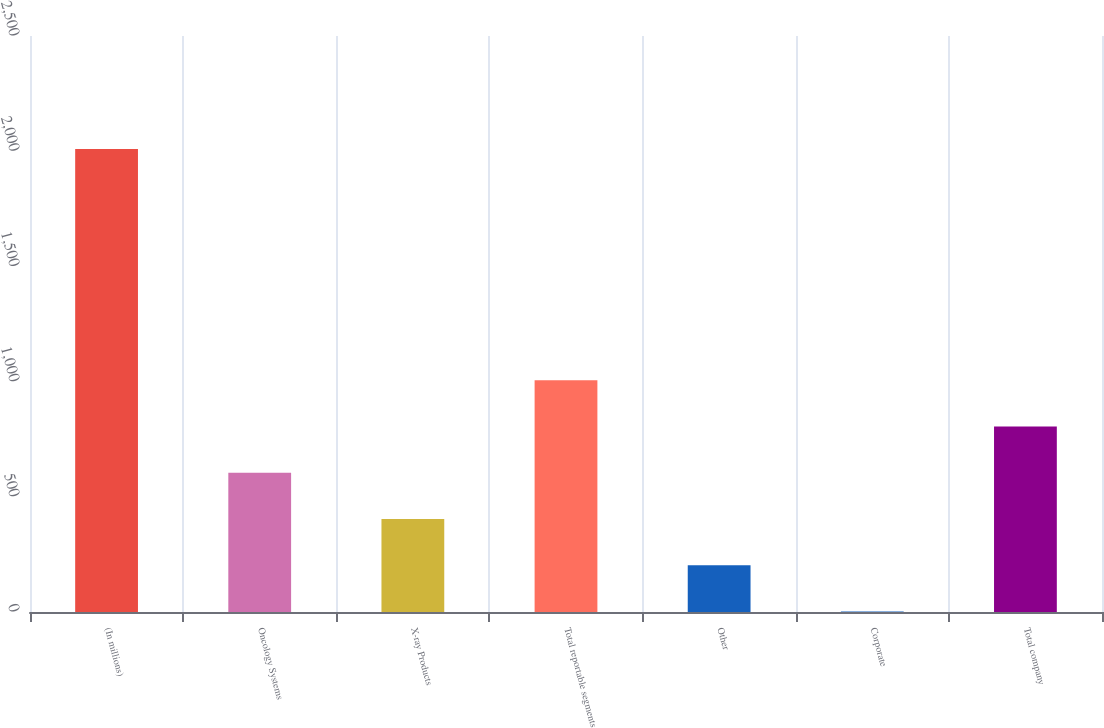Convert chart. <chart><loc_0><loc_0><loc_500><loc_500><bar_chart><fcel>(In millions)<fcel>Oncology Systems<fcel>X-ray Products<fcel>Total reportable segments<fcel>Other<fcel>Corporate<fcel>Total company<nl><fcel>2010<fcel>604.4<fcel>403.6<fcel>1006<fcel>202.8<fcel>2<fcel>805.2<nl></chart> 